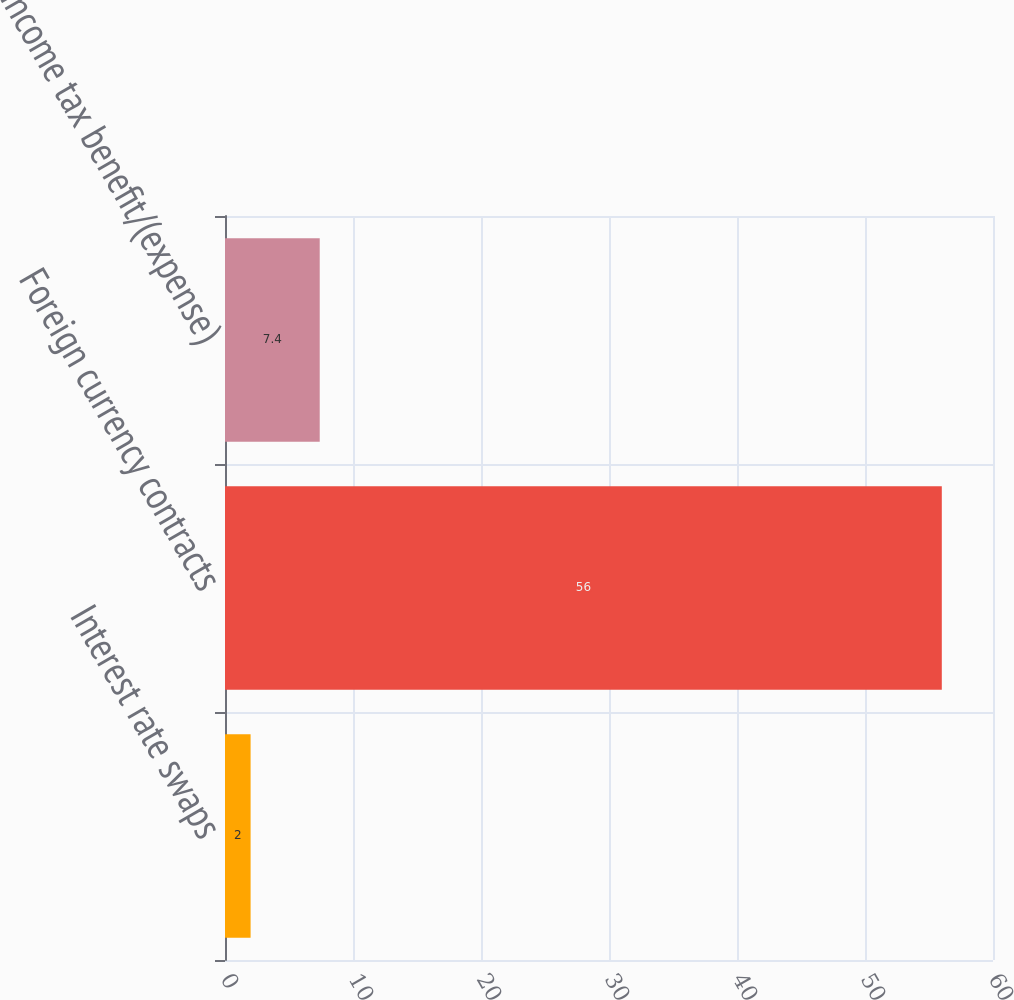Convert chart to OTSL. <chart><loc_0><loc_0><loc_500><loc_500><bar_chart><fcel>Interest rate swaps<fcel>Foreign currency contracts<fcel>Income tax benefit/(expense)<nl><fcel>2<fcel>56<fcel>7.4<nl></chart> 